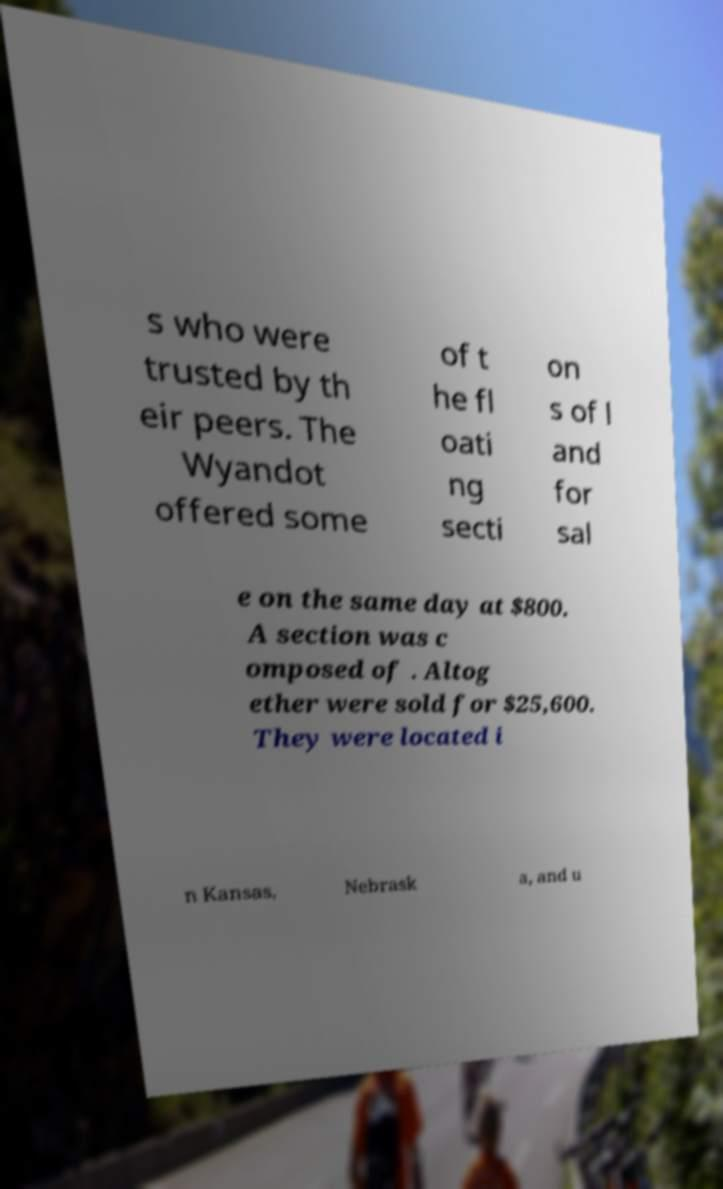Please read and relay the text visible in this image. What does it say? s who were trusted by th eir peers. The Wyandot offered some of t he fl oati ng secti on s of l and for sal e on the same day at $800. A section was c omposed of . Altog ether were sold for $25,600. They were located i n Kansas, Nebrask a, and u 